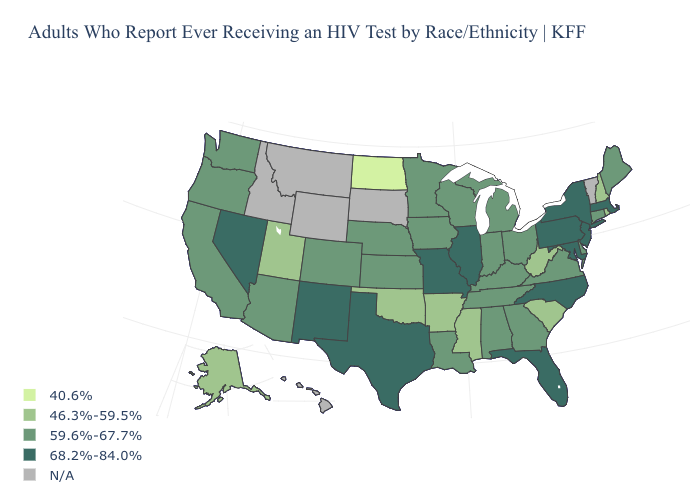What is the value of Tennessee?
Answer briefly. 59.6%-67.7%. Name the states that have a value in the range 59.6%-67.7%?
Quick response, please. Alabama, Arizona, California, Colorado, Connecticut, Delaware, Georgia, Indiana, Iowa, Kansas, Kentucky, Louisiana, Maine, Michigan, Minnesota, Nebraska, Ohio, Oregon, Tennessee, Virginia, Washington, Wisconsin. What is the value of Rhode Island?
Short answer required. 46.3%-59.5%. Which states have the highest value in the USA?
Keep it brief. Florida, Illinois, Maryland, Massachusetts, Missouri, Nevada, New Jersey, New Mexico, New York, North Carolina, Pennsylvania, Texas. How many symbols are there in the legend?
Short answer required. 5. What is the value of New Jersey?
Answer briefly. 68.2%-84.0%. What is the value of Minnesota?
Short answer required. 59.6%-67.7%. Does Iowa have the highest value in the USA?
Be succinct. No. What is the value of Iowa?
Write a very short answer. 59.6%-67.7%. Does North Dakota have the lowest value in the USA?
Write a very short answer. Yes. What is the lowest value in states that border Connecticut?
Short answer required. 46.3%-59.5%. Does New Hampshire have the lowest value in the Northeast?
Give a very brief answer. Yes. What is the value of Ohio?
Concise answer only. 59.6%-67.7%. 